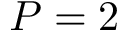Convert formula to latex. <formula><loc_0><loc_0><loc_500><loc_500>P = 2</formula> 